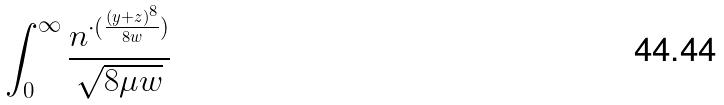<formula> <loc_0><loc_0><loc_500><loc_500>\int _ { 0 } ^ { \infty } \frac { n ^ { \cdot ( \frac { ( y + z ) ^ { 8 } } { 8 w } ) } } { \sqrt { 8 \mu w } }</formula> 